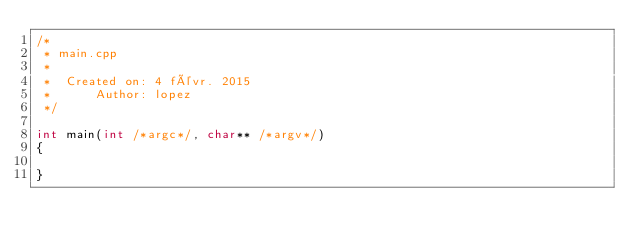Convert code to text. <code><loc_0><loc_0><loc_500><loc_500><_C++_>/*
 * main.cpp
 *
 *  Created on: 4 févr. 2015
 *      Author: lopez
 */

int main(int /*argc*/, char** /*argv*/)
{

}
</code> 